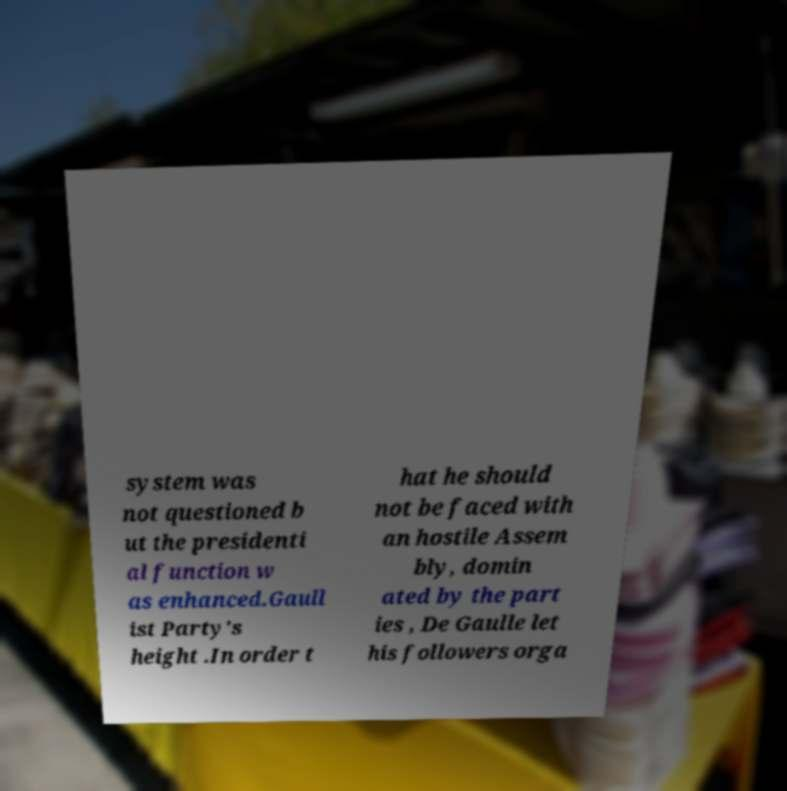For documentation purposes, I need the text within this image transcribed. Could you provide that? system was not questioned b ut the presidenti al function w as enhanced.Gaull ist Party's height .In order t hat he should not be faced with an hostile Assem bly, domin ated by the part ies , De Gaulle let his followers orga 